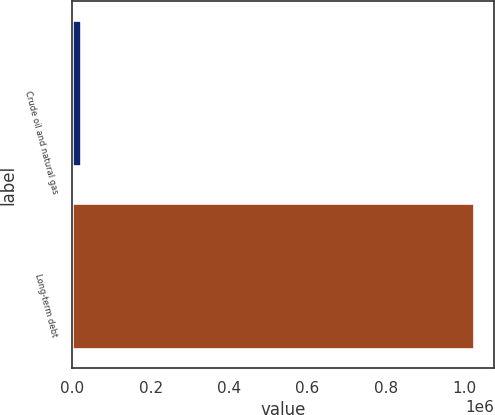<chart> <loc_0><loc_0><loc_500><loc_500><bar_chart><fcel>Crude oil and natural gas<fcel>Long-term debt<nl><fcel>22520<fcel>1.02525e+06<nl></chart> 